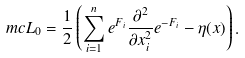<formula> <loc_0><loc_0><loc_500><loc_500>\ m c { L } _ { 0 } = \frac { 1 } { 2 } \left ( \sum _ { i = 1 } ^ { n } e ^ { F _ { i } } \frac { \partial ^ { 2 } } { \partial x _ { i } ^ { 2 } } e ^ { - F _ { i } } - \eta ( x ) \right ) .</formula> 